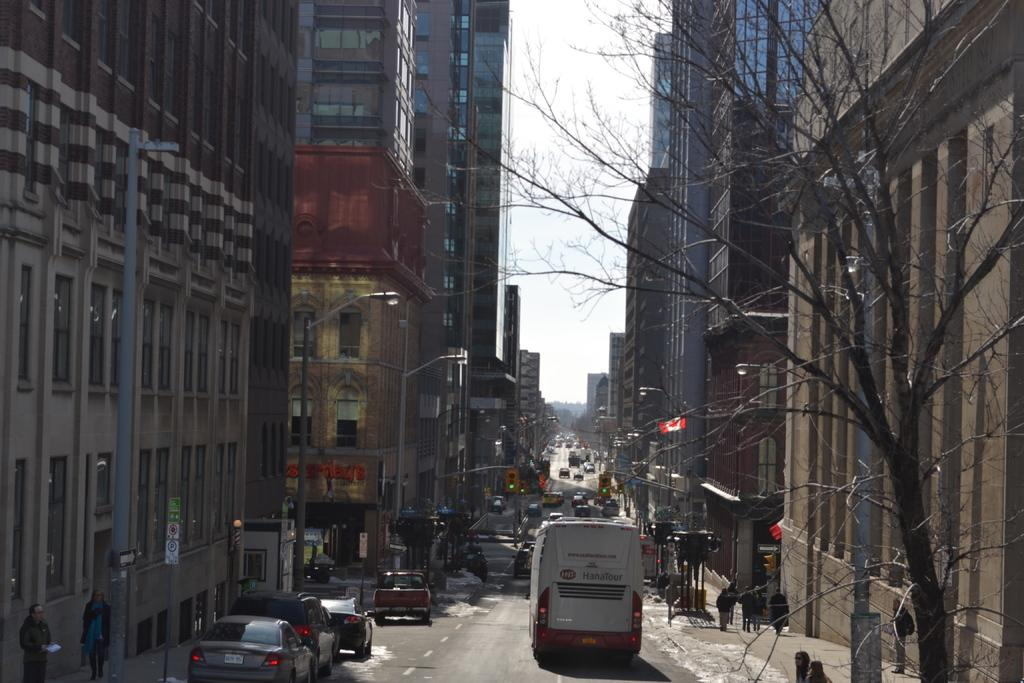What can be seen on the road in the image? There are vehicles on the road in the image. What is located beside the road in the image? There is a tree beside the road in the image. What type of structures are visible in the image? There are buildings in the image. Can you read the note that is attached to the tree in the image? There is no note attached to the tree in the image. How many clams can be seen on the road in the image? There are no clams present in the image. 